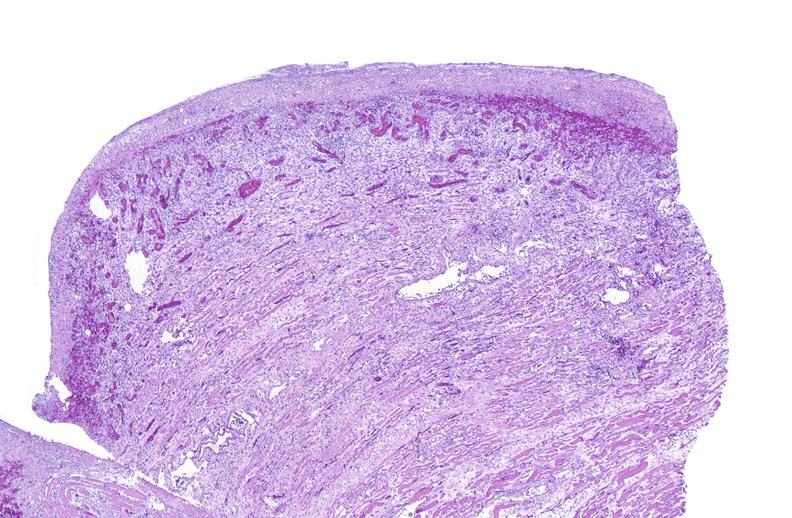what is present?
Answer the question using a single word or phrase. Soft tissue 